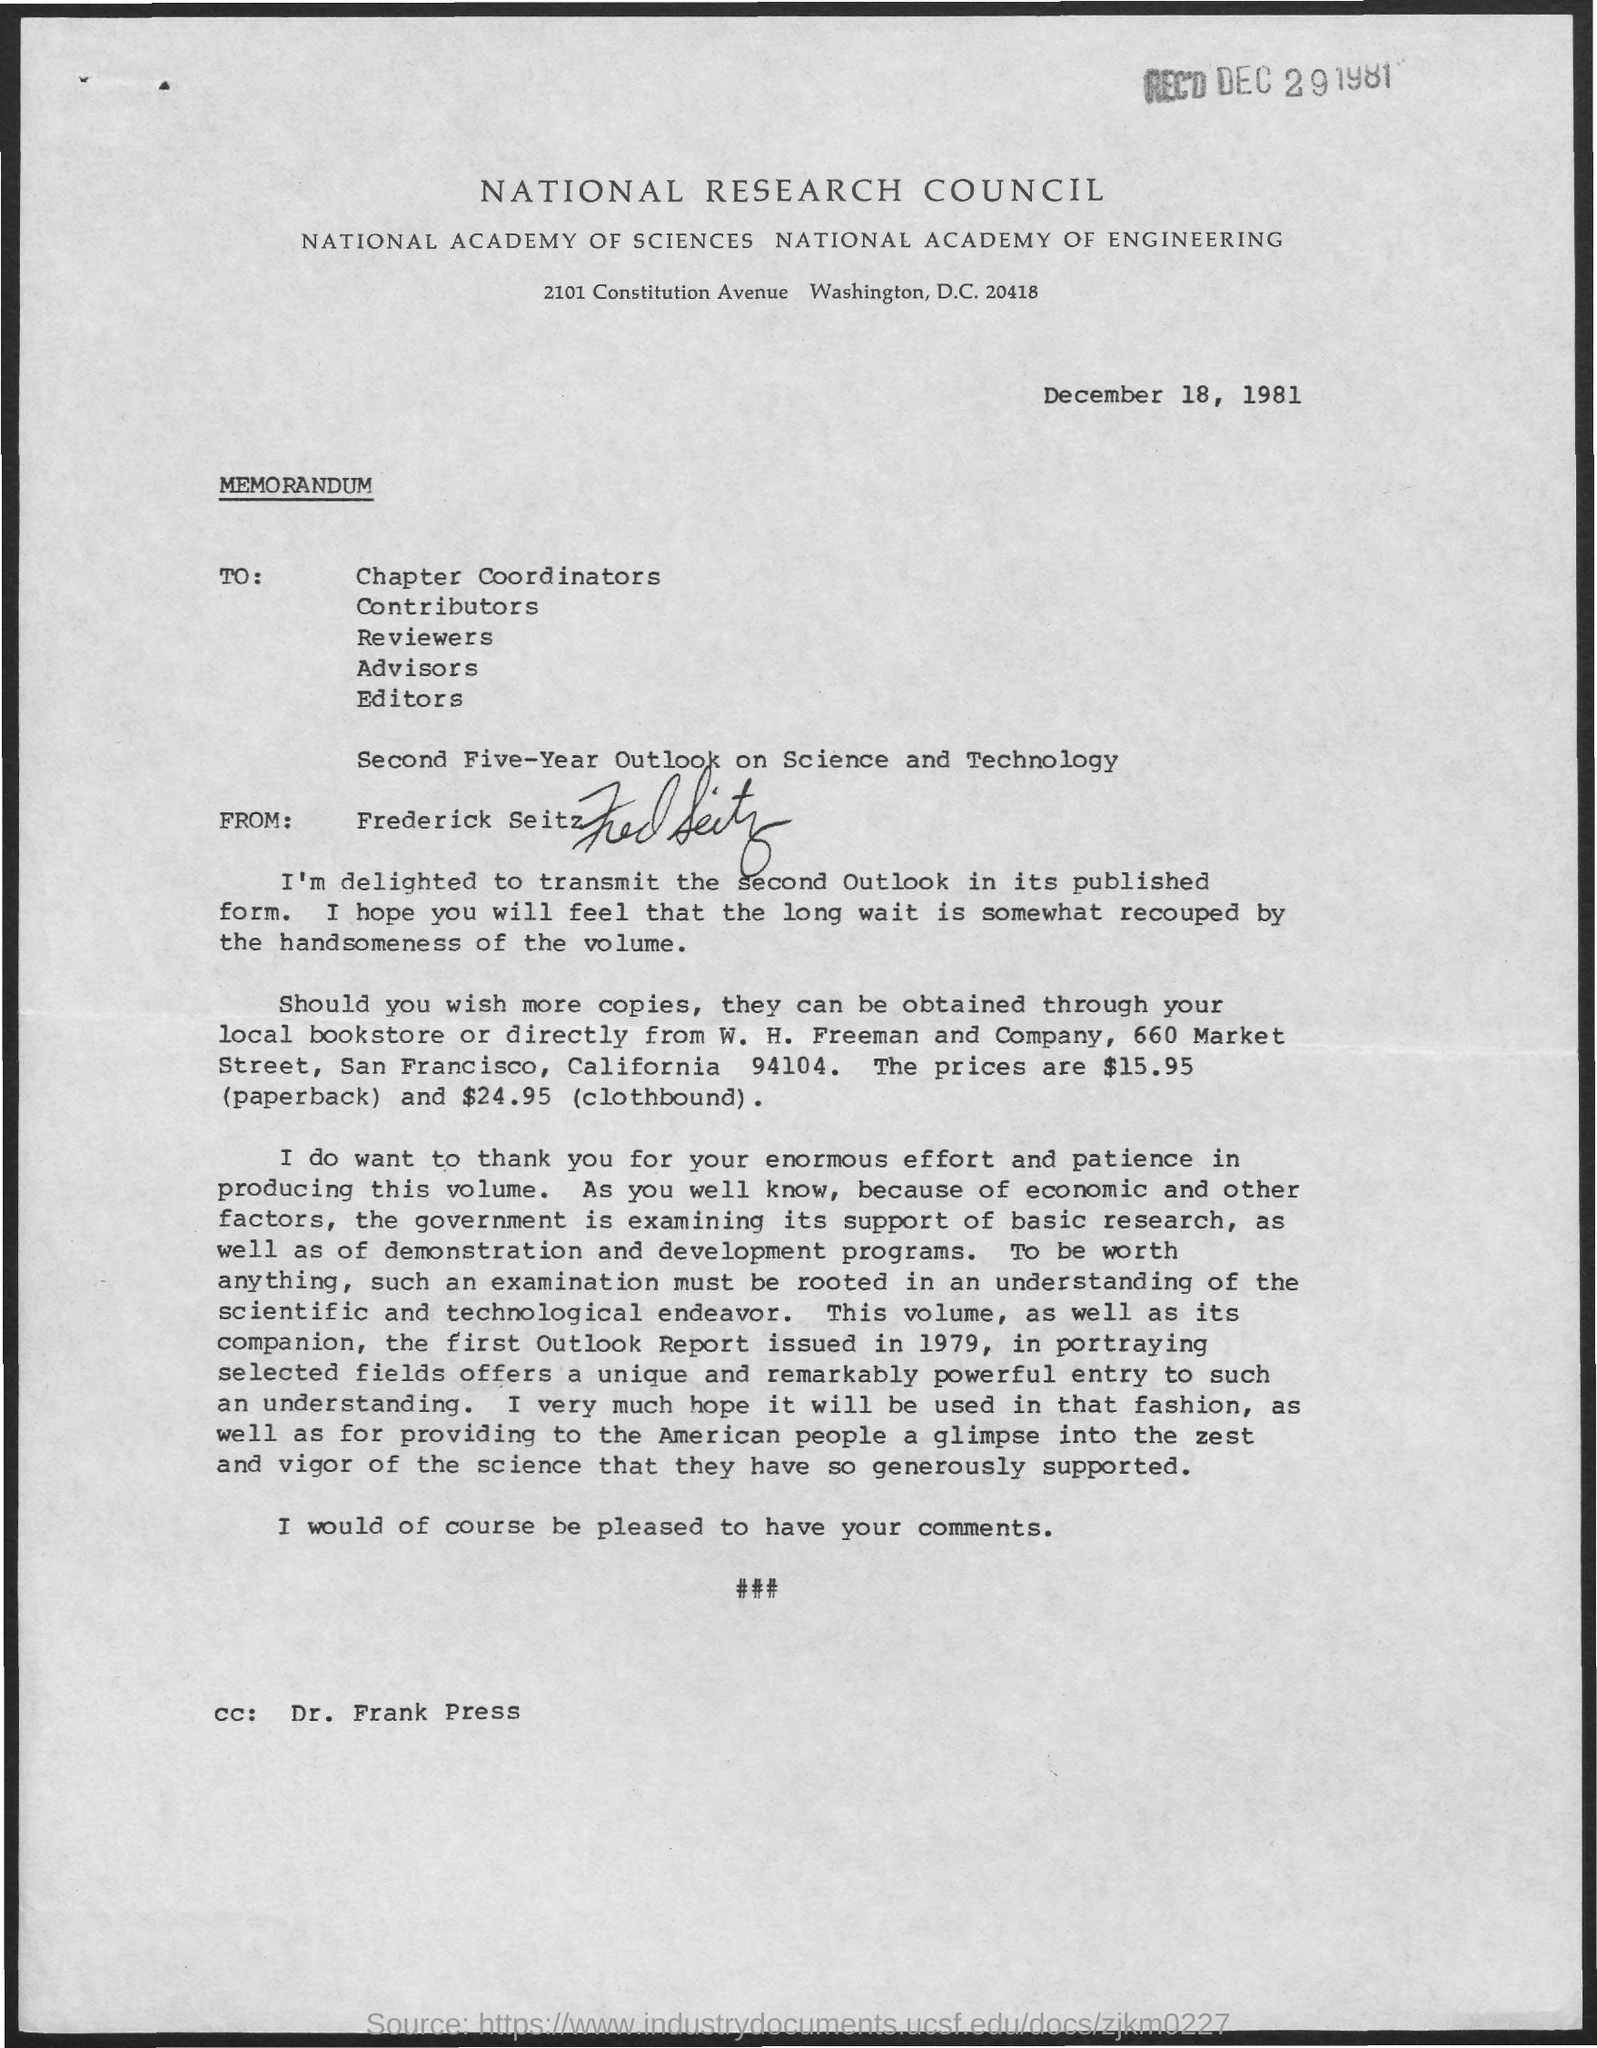What type of document is this?
Give a very brief answer. Memorandum. What is the issued date of this memorandum?
Provide a succinct answer. December 18, 1981. Who is the sender of this memorandum?
Offer a terse response. Frederick Seitz. Who is in the cc of the memorandum?
Provide a succinct answer. Dr. Frank Press. 